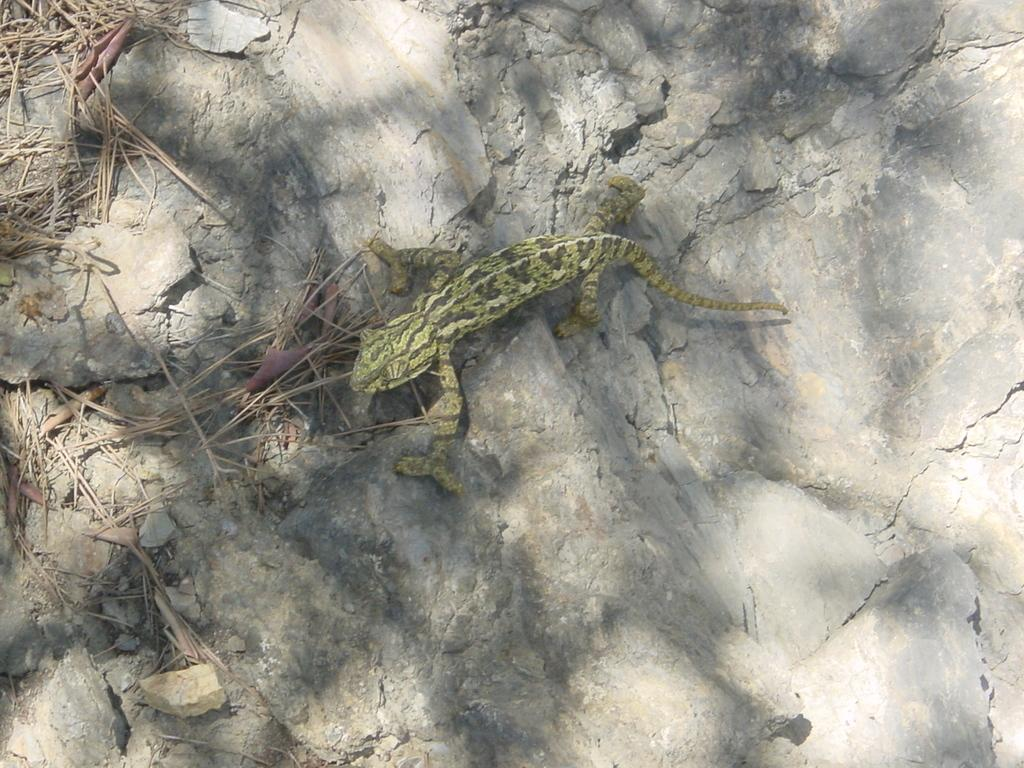What type of animal is in the image? There is a reptile in the image. What color is the reptile? The reptile is green in color. Where is the reptile located in the image? The reptile is on a rock surface. What color is the rock surface? The rock surface is ash in color. What type of vegetation is in the image? There is some grass in the image. What color is the grass? The grass is brown in color. Where is the grass located in the image? The grass is on the rock surface. What type of riddle is the reptile solving in the image? There is no riddle present in the image, nor is the reptile solving any riddle. What kind of structure can be seen in the background of the image? There is no structure visible in the image; it only features the reptile, rock surface, and grass. 